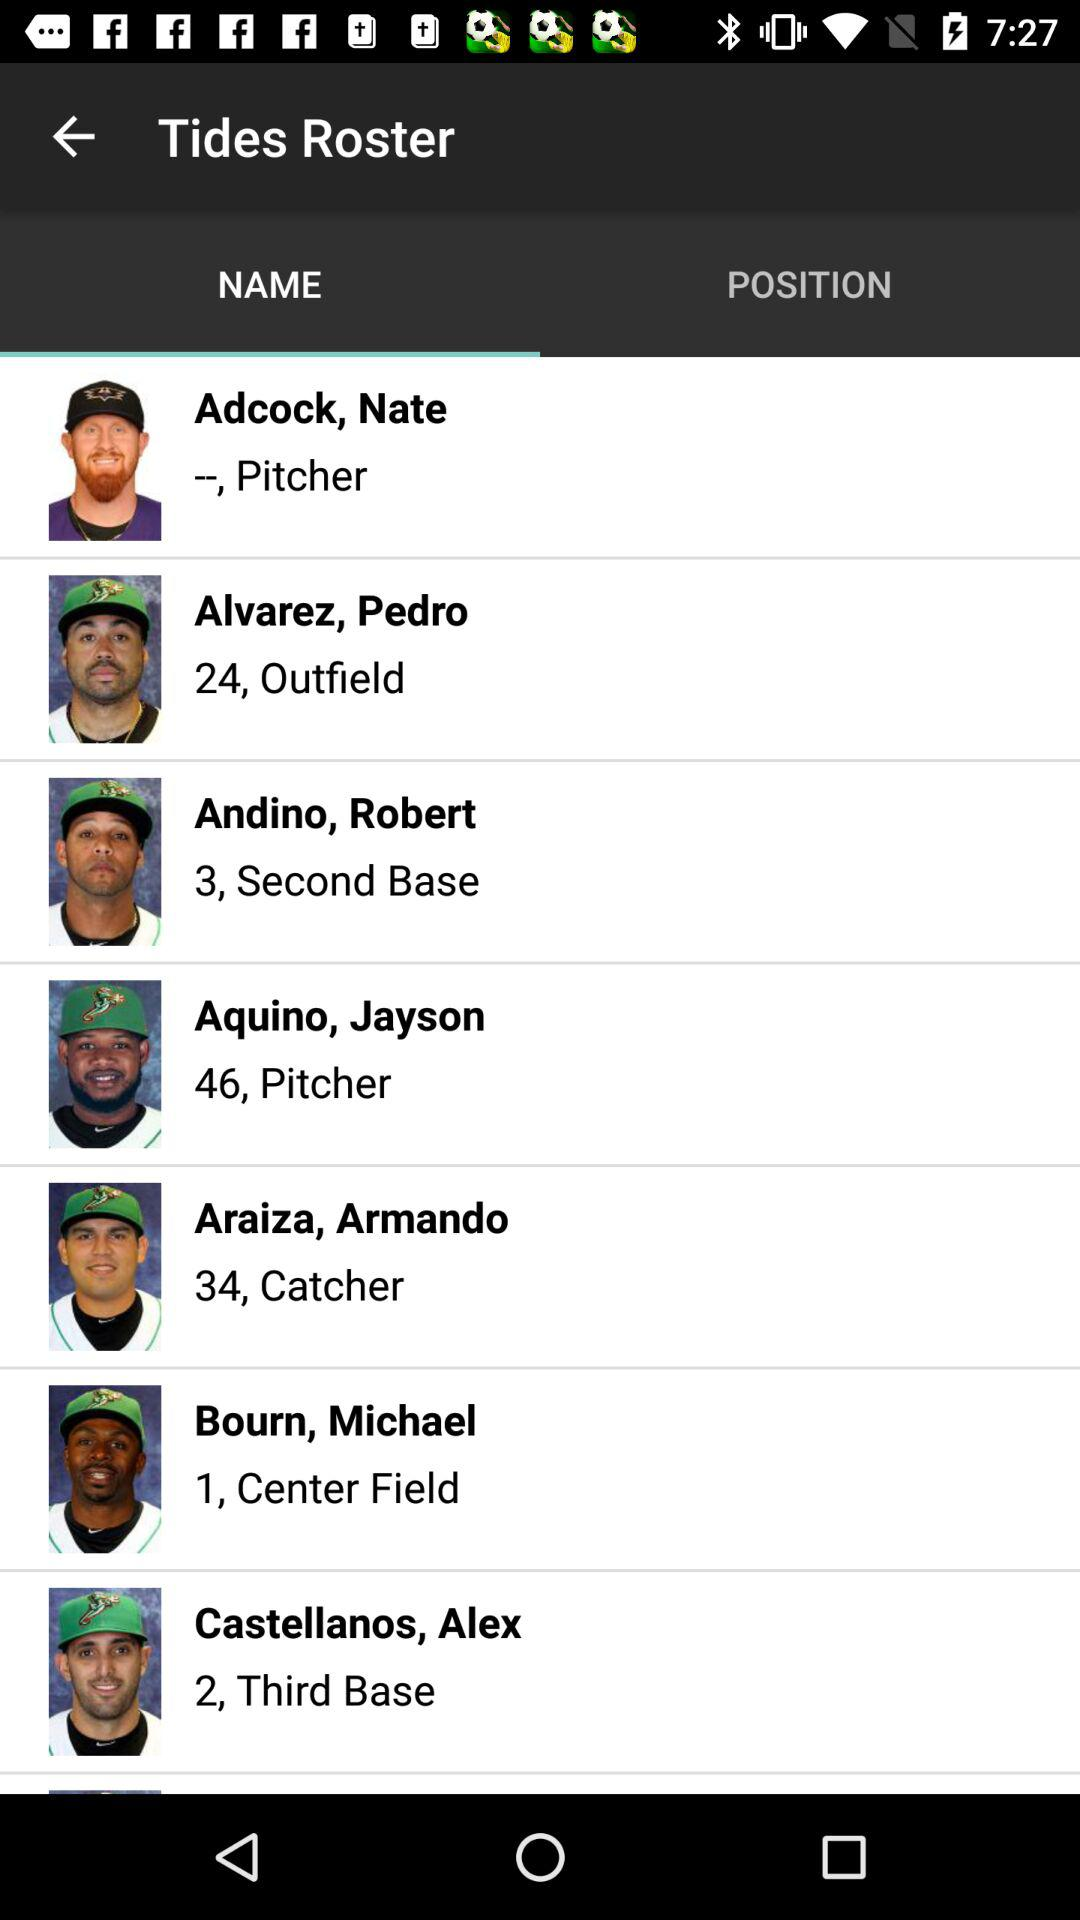Which player is at third base? The player is Alex Castellanos. 